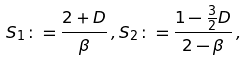Convert formula to latex. <formula><loc_0><loc_0><loc_500><loc_500>S _ { 1 } \colon = \frac { 2 + D } { \beta } \, , S _ { 2 } \colon = \frac { 1 - \frac { 3 } { 2 } D } { 2 - \beta } \, ,</formula> 